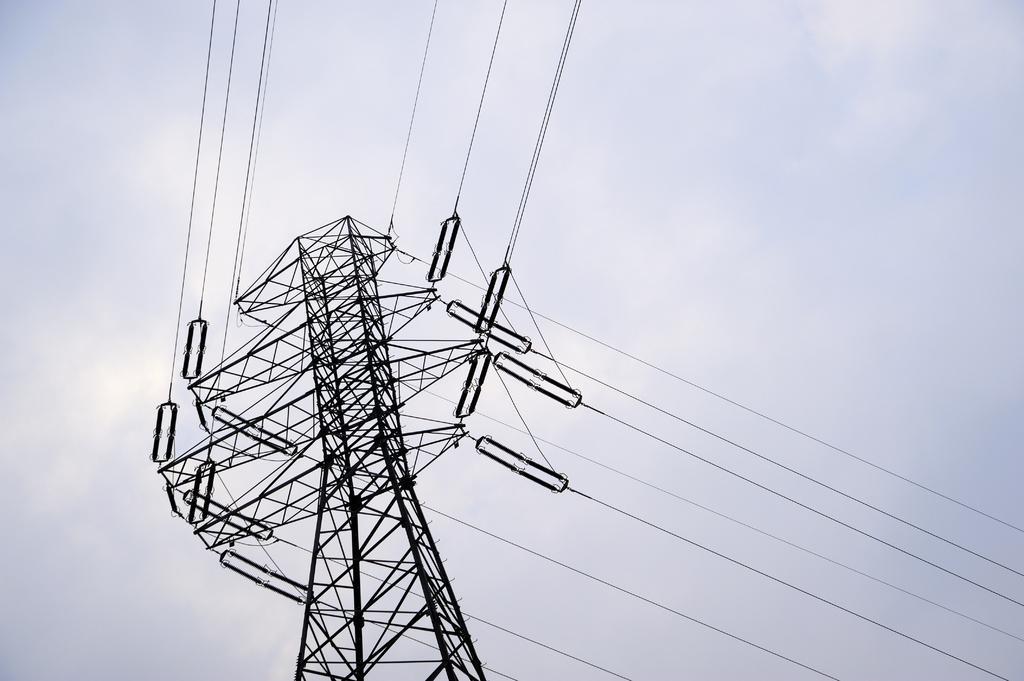Can you describe this image briefly? It is the image of a tower it looks like a cell phone tower,there are multiple links attached to the wires from the tower,in the background there is a sky. 